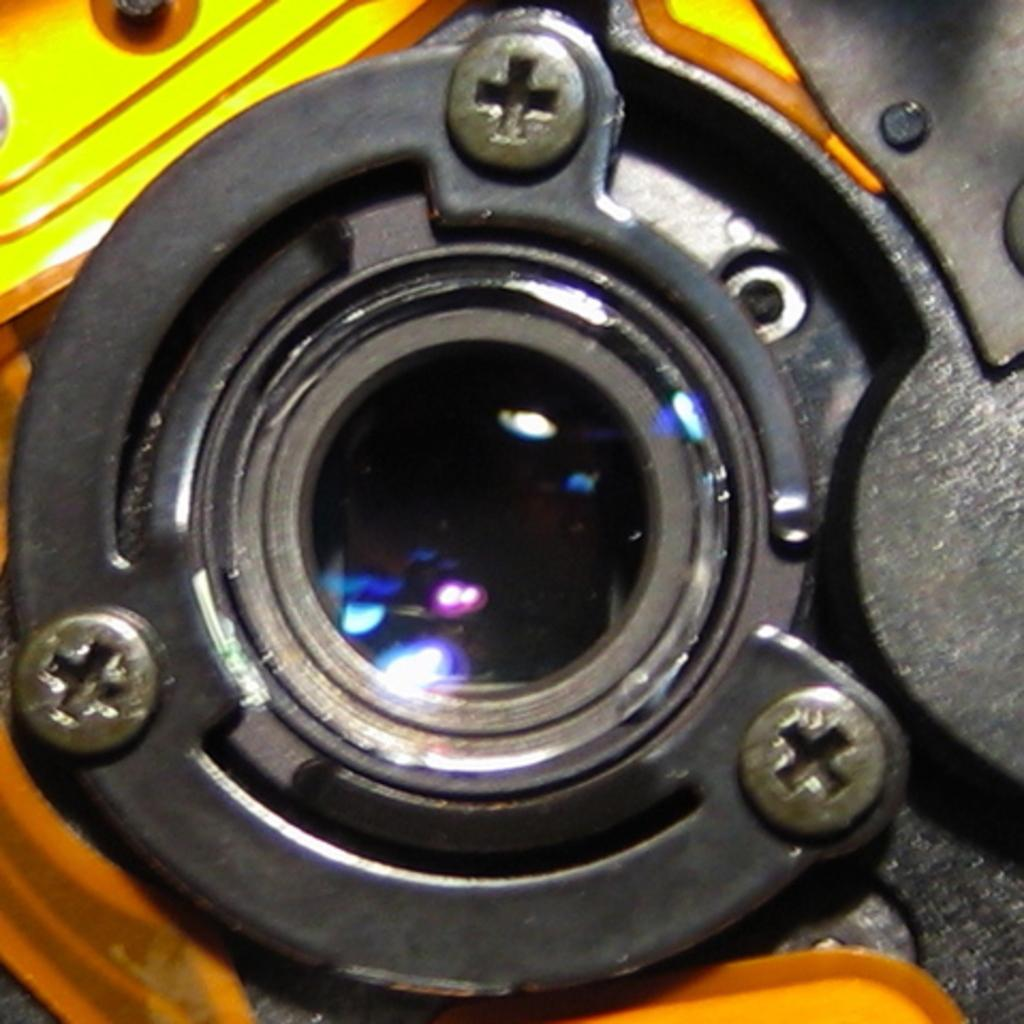What can be seen in the image? There is an object in the image. What colors are present on the object? The object has a black and yellow color. What type of jewel is present in the image? There is no jewel present in the image; the object has a black and yellow color, but it is not specified as a jewel. 